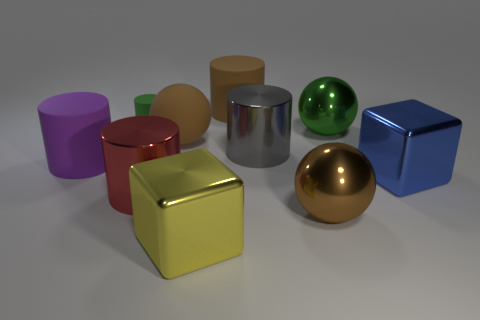There is a cylinder that is both to the right of the yellow block and in front of the small green matte thing; what color is it?
Your response must be concise. Gray. Is there a gray metallic thing that has the same shape as the blue object?
Provide a short and direct response. No. What material is the large green object?
Offer a very short reply. Metal. There is a big gray object; are there any big metal cylinders in front of it?
Your answer should be compact. Yes. Does the yellow metal object have the same shape as the blue object?
Your response must be concise. Yes. What number of other things are the same size as the red thing?
Make the answer very short. 8. How many objects are large cubes to the left of the big brown matte cylinder or blue metal things?
Ensure brevity in your answer.  2. What is the color of the tiny matte cylinder?
Make the answer very short. Green. There is a green thing that is in front of the tiny green cylinder; what is its material?
Your answer should be compact. Metal. Do the large purple matte object and the gray metal object behind the big blue metallic thing have the same shape?
Give a very brief answer. Yes. 